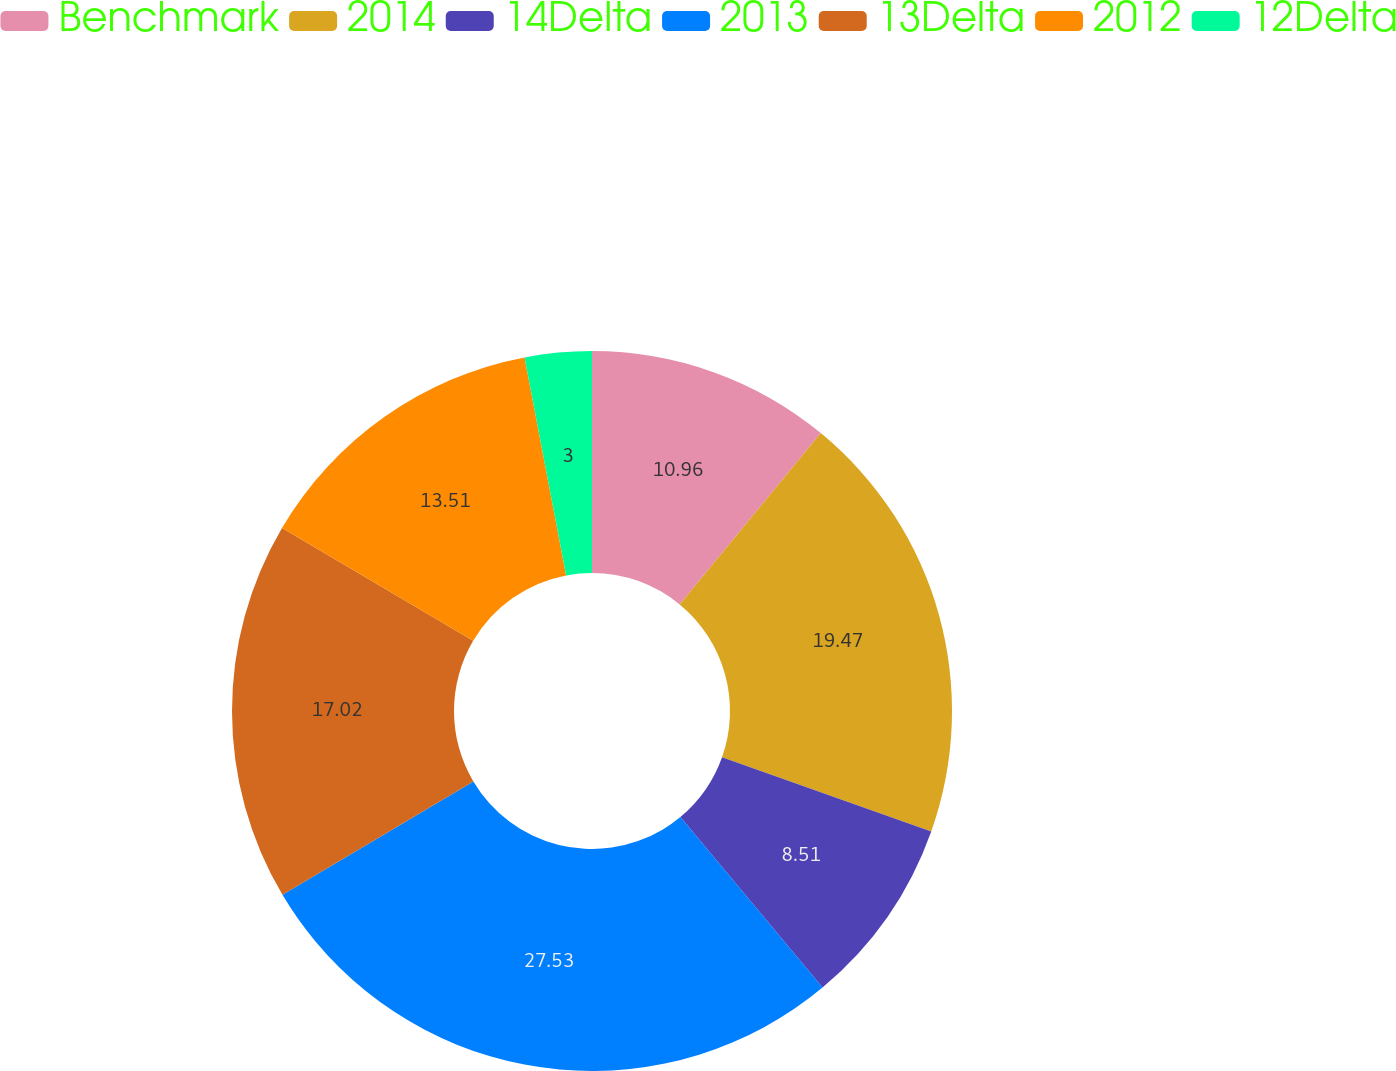Convert chart. <chart><loc_0><loc_0><loc_500><loc_500><pie_chart><fcel>Benchmark<fcel>2014<fcel>14Delta<fcel>2013<fcel>13Delta<fcel>2012<fcel>12Delta<nl><fcel>10.96%<fcel>19.47%<fcel>8.51%<fcel>27.53%<fcel>17.02%<fcel>13.51%<fcel>3.0%<nl></chart> 